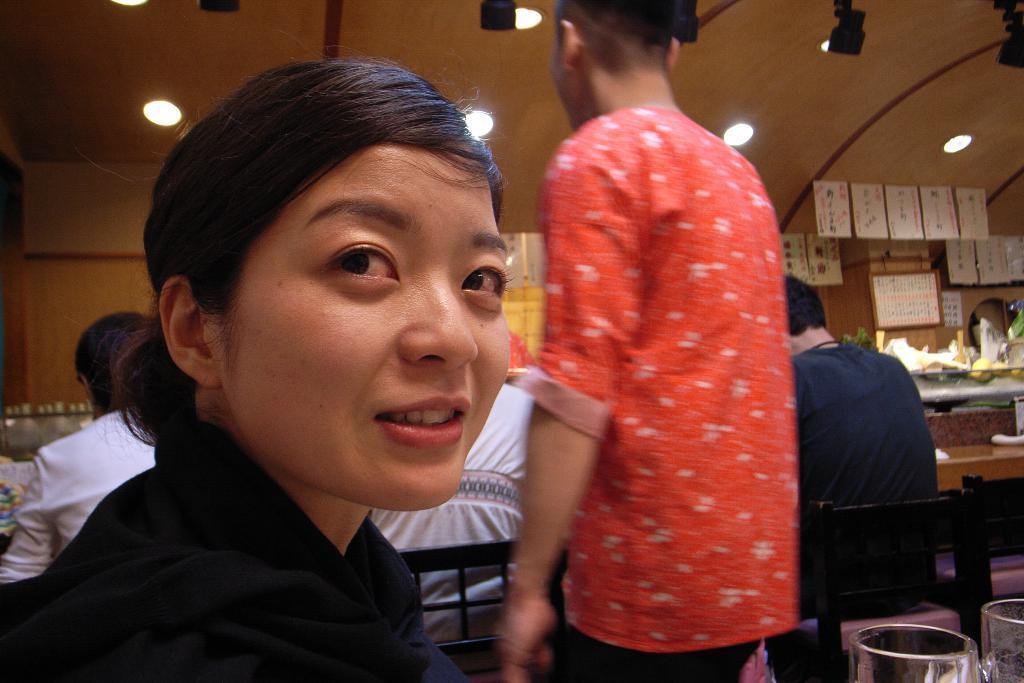Please provide a concise description of this image. There is one woman wearing a black color dress is at the bottom of this image. We can see other people in the background. There are objects kept on the table, we can see on the right side of this image. We can see lights attached to the roof is at the top of this image. 